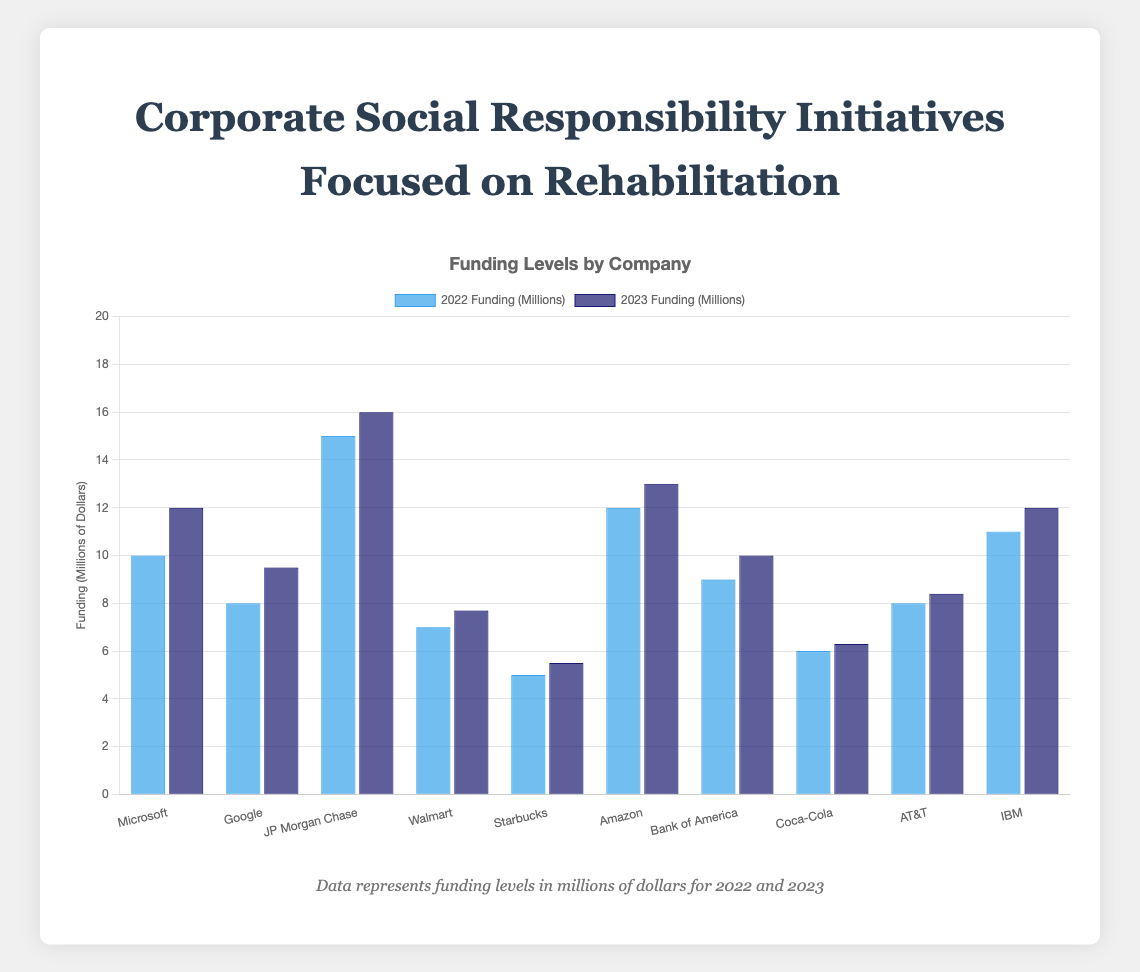What was the total funding for Microsoft in 2022 and 2023 combined? Add the funding for Microsoft in 2022 and 2023: 10 + 12 = 22 million dollars.
Answer: 22 million dollars Which company had the highest funding in 2022? The highest bar in the 2022 funding section corresponds to JP Morgan Chase with 15 million dollars.
Answer: JP Morgan Chase Which company saw the largest increase in funding from 2022 to 2023? Calculate the change in funding for each company and find the largest: Microsoft (2), Google (1.5), JP Morgan Chase (1), Walmart (0.7), Starbucks (0.5), Amazon (1), Bank of America (1), Coca-Cola (0.3), AT&T (0.4), IBM (1). The largest increase is for Microsoft with 2 million dollars.
Answer: Microsoft What are the funding amounts for IBM in 2022 and 2023 respectively? Look at the bars for IBM: they are 11 million dollars for 2022 and 12 million dollars for 2023.
Answer: 11 million dollars (2022), 12 million dollars (2023) Which company's funding amount remained below 10 million dollars in both 2022 and 2023? Identify bars for which both years are below 10 million: Google, Walmart, Starbucks, Coca-Cola, AT&T.
Answer: Google, Walmart, Starbucks, Coca-Cola, AT&T What's the average 2023 funding across all companies? Add the 2023 funding amounts and divide by the number of companies: (12 + 9.5 + 16 + 7.7 + 5.5 + 13 + 10 + 6.3 + 8.4 + 12)/10 = 100.4/10 = 10.04 million dollars.
Answer: 10.04 million dollars Which company had equal funding in both 2022 and 2023? No company has bars of the same height for 2022 and 2023.
Answer: None Among Microsoft, Amazon, and IBM, which had the highest funding in 2023? Compare the bars for Microsoft (12), Amazon (13), and IBM (12) in 2023. Amazon has the highest funding at 13 million dollars.
Answer: Amazon What's the difference in 2023 funding between the companies with the highest and lowest amounts? The highest 2023 funding is from JP Morgan Chase at 16 million dollars, and the lowest is Starbucks at 5.5 million dollars. The difference is 16 - 5.5 = 10.5 million dollars.
Answer: 10.5 million dollars 